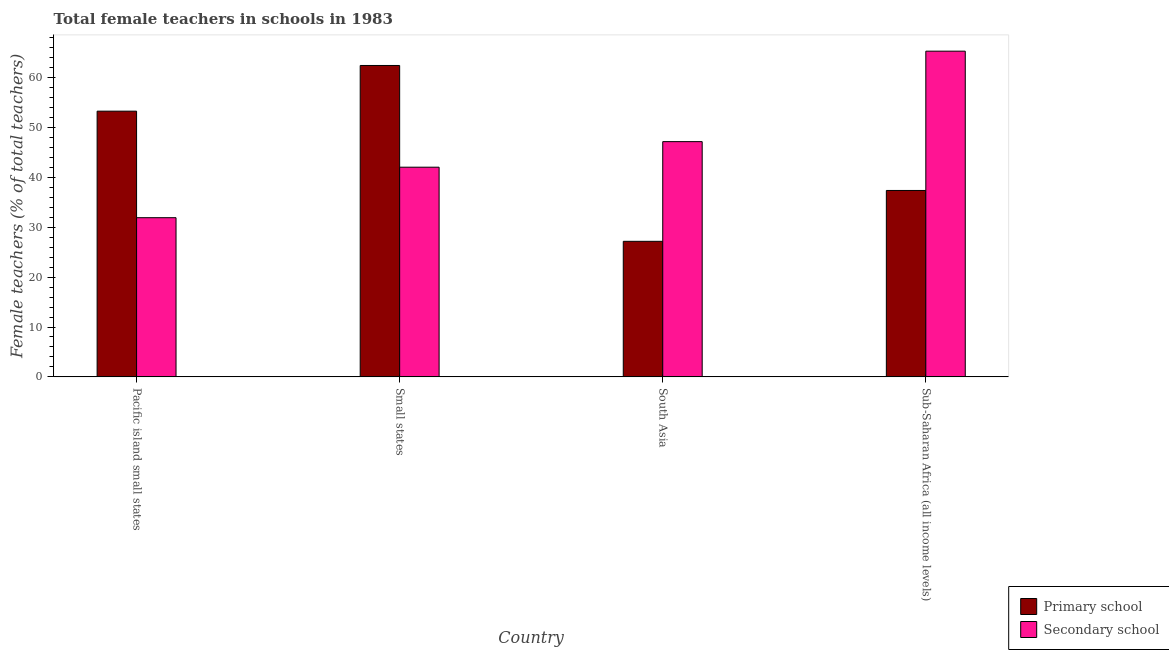How many different coloured bars are there?
Your response must be concise. 2. How many groups of bars are there?
Ensure brevity in your answer.  4. Are the number of bars per tick equal to the number of legend labels?
Your answer should be very brief. Yes. Are the number of bars on each tick of the X-axis equal?
Your response must be concise. Yes. How many bars are there on the 4th tick from the left?
Your answer should be very brief. 2. What is the label of the 4th group of bars from the left?
Give a very brief answer. Sub-Saharan Africa (all income levels). In how many cases, is the number of bars for a given country not equal to the number of legend labels?
Your answer should be very brief. 0. What is the percentage of female teachers in primary schools in Sub-Saharan Africa (all income levels)?
Give a very brief answer. 37.4. Across all countries, what is the maximum percentage of female teachers in primary schools?
Your answer should be very brief. 62.47. Across all countries, what is the minimum percentage of female teachers in primary schools?
Offer a terse response. 27.19. In which country was the percentage of female teachers in secondary schools maximum?
Ensure brevity in your answer.  Sub-Saharan Africa (all income levels). In which country was the percentage of female teachers in secondary schools minimum?
Your answer should be compact. Pacific island small states. What is the total percentage of female teachers in primary schools in the graph?
Offer a very short reply. 180.37. What is the difference between the percentage of female teachers in primary schools in Pacific island small states and that in Sub-Saharan Africa (all income levels)?
Your answer should be compact. 15.91. What is the difference between the percentage of female teachers in primary schools in Small states and the percentage of female teachers in secondary schools in South Asia?
Give a very brief answer. 15.28. What is the average percentage of female teachers in secondary schools per country?
Make the answer very short. 46.63. What is the difference between the percentage of female teachers in primary schools and percentage of female teachers in secondary schools in Small states?
Give a very brief answer. 20.41. What is the ratio of the percentage of female teachers in primary schools in South Asia to that in Sub-Saharan Africa (all income levels)?
Your answer should be compact. 0.73. Is the difference between the percentage of female teachers in primary schools in Pacific island small states and Sub-Saharan Africa (all income levels) greater than the difference between the percentage of female teachers in secondary schools in Pacific island small states and Sub-Saharan Africa (all income levels)?
Provide a succinct answer. Yes. What is the difference between the highest and the second highest percentage of female teachers in secondary schools?
Your answer should be very brief. 18.15. What is the difference between the highest and the lowest percentage of female teachers in secondary schools?
Provide a short and direct response. 33.41. In how many countries, is the percentage of female teachers in primary schools greater than the average percentage of female teachers in primary schools taken over all countries?
Your response must be concise. 2. Is the sum of the percentage of female teachers in primary schools in Pacific island small states and Sub-Saharan Africa (all income levels) greater than the maximum percentage of female teachers in secondary schools across all countries?
Make the answer very short. Yes. What does the 1st bar from the left in Pacific island small states represents?
Provide a short and direct response. Primary school. What does the 2nd bar from the right in South Asia represents?
Provide a succinct answer. Primary school. How many countries are there in the graph?
Provide a succinct answer. 4. What is the difference between two consecutive major ticks on the Y-axis?
Keep it short and to the point. 10. Does the graph contain any zero values?
Keep it short and to the point. No. Where does the legend appear in the graph?
Provide a succinct answer. Bottom right. How many legend labels are there?
Ensure brevity in your answer.  2. How are the legend labels stacked?
Keep it short and to the point. Vertical. What is the title of the graph?
Keep it short and to the point. Total female teachers in schools in 1983. Does "GDP at market prices" appear as one of the legend labels in the graph?
Offer a very short reply. No. What is the label or title of the Y-axis?
Give a very brief answer. Female teachers (% of total teachers). What is the Female teachers (% of total teachers) in Primary school in Pacific island small states?
Your response must be concise. 53.31. What is the Female teachers (% of total teachers) of Secondary school in Pacific island small states?
Provide a short and direct response. 31.94. What is the Female teachers (% of total teachers) in Primary school in Small states?
Your answer should be very brief. 62.47. What is the Female teachers (% of total teachers) in Secondary school in Small states?
Provide a short and direct response. 42.07. What is the Female teachers (% of total teachers) of Primary school in South Asia?
Make the answer very short. 27.19. What is the Female teachers (% of total teachers) of Secondary school in South Asia?
Provide a succinct answer. 47.19. What is the Female teachers (% of total teachers) of Primary school in Sub-Saharan Africa (all income levels)?
Make the answer very short. 37.4. What is the Female teachers (% of total teachers) in Secondary school in Sub-Saharan Africa (all income levels)?
Make the answer very short. 65.34. Across all countries, what is the maximum Female teachers (% of total teachers) in Primary school?
Offer a terse response. 62.47. Across all countries, what is the maximum Female teachers (% of total teachers) in Secondary school?
Offer a very short reply. 65.34. Across all countries, what is the minimum Female teachers (% of total teachers) of Primary school?
Give a very brief answer. 27.19. Across all countries, what is the minimum Female teachers (% of total teachers) in Secondary school?
Provide a succinct answer. 31.94. What is the total Female teachers (% of total teachers) in Primary school in the graph?
Offer a terse response. 180.37. What is the total Female teachers (% of total teachers) in Secondary school in the graph?
Make the answer very short. 186.54. What is the difference between the Female teachers (% of total teachers) of Primary school in Pacific island small states and that in Small states?
Offer a very short reply. -9.17. What is the difference between the Female teachers (% of total teachers) of Secondary school in Pacific island small states and that in Small states?
Provide a succinct answer. -10.13. What is the difference between the Female teachers (% of total teachers) of Primary school in Pacific island small states and that in South Asia?
Give a very brief answer. 26.11. What is the difference between the Female teachers (% of total teachers) in Secondary school in Pacific island small states and that in South Asia?
Give a very brief answer. -15.26. What is the difference between the Female teachers (% of total teachers) in Primary school in Pacific island small states and that in Sub-Saharan Africa (all income levels)?
Provide a short and direct response. 15.91. What is the difference between the Female teachers (% of total teachers) in Secondary school in Pacific island small states and that in Sub-Saharan Africa (all income levels)?
Ensure brevity in your answer.  -33.41. What is the difference between the Female teachers (% of total teachers) of Primary school in Small states and that in South Asia?
Keep it short and to the point. 35.28. What is the difference between the Female teachers (% of total teachers) of Secondary school in Small states and that in South Asia?
Your answer should be compact. -5.13. What is the difference between the Female teachers (% of total teachers) in Primary school in Small states and that in Sub-Saharan Africa (all income levels)?
Offer a terse response. 25.07. What is the difference between the Female teachers (% of total teachers) in Secondary school in Small states and that in Sub-Saharan Africa (all income levels)?
Offer a very short reply. -23.28. What is the difference between the Female teachers (% of total teachers) of Primary school in South Asia and that in Sub-Saharan Africa (all income levels)?
Your answer should be very brief. -10.2. What is the difference between the Female teachers (% of total teachers) in Secondary school in South Asia and that in Sub-Saharan Africa (all income levels)?
Offer a terse response. -18.15. What is the difference between the Female teachers (% of total teachers) of Primary school in Pacific island small states and the Female teachers (% of total teachers) of Secondary school in Small states?
Keep it short and to the point. 11.24. What is the difference between the Female teachers (% of total teachers) of Primary school in Pacific island small states and the Female teachers (% of total teachers) of Secondary school in South Asia?
Offer a terse response. 6.11. What is the difference between the Female teachers (% of total teachers) of Primary school in Pacific island small states and the Female teachers (% of total teachers) of Secondary school in Sub-Saharan Africa (all income levels)?
Your answer should be compact. -12.04. What is the difference between the Female teachers (% of total teachers) in Primary school in Small states and the Female teachers (% of total teachers) in Secondary school in South Asia?
Keep it short and to the point. 15.28. What is the difference between the Female teachers (% of total teachers) in Primary school in Small states and the Female teachers (% of total teachers) in Secondary school in Sub-Saharan Africa (all income levels)?
Provide a short and direct response. -2.87. What is the difference between the Female teachers (% of total teachers) of Primary school in South Asia and the Female teachers (% of total teachers) of Secondary school in Sub-Saharan Africa (all income levels)?
Offer a terse response. -38.15. What is the average Female teachers (% of total teachers) in Primary school per country?
Your answer should be very brief. 45.09. What is the average Female teachers (% of total teachers) of Secondary school per country?
Offer a terse response. 46.63. What is the difference between the Female teachers (% of total teachers) of Primary school and Female teachers (% of total teachers) of Secondary school in Pacific island small states?
Make the answer very short. 21.37. What is the difference between the Female teachers (% of total teachers) in Primary school and Female teachers (% of total teachers) in Secondary school in Small states?
Make the answer very short. 20.41. What is the difference between the Female teachers (% of total teachers) of Primary school and Female teachers (% of total teachers) of Secondary school in South Asia?
Keep it short and to the point. -20. What is the difference between the Female teachers (% of total teachers) in Primary school and Female teachers (% of total teachers) in Secondary school in Sub-Saharan Africa (all income levels)?
Make the answer very short. -27.95. What is the ratio of the Female teachers (% of total teachers) in Primary school in Pacific island small states to that in Small states?
Provide a succinct answer. 0.85. What is the ratio of the Female teachers (% of total teachers) of Secondary school in Pacific island small states to that in Small states?
Your response must be concise. 0.76. What is the ratio of the Female teachers (% of total teachers) of Primary school in Pacific island small states to that in South Asia?
Your answer should be very brief. 1.96. What is the ratio of the Female teachers (% of total teachers) of Secondary school in Pacific island small states to that in South Asia?
Provide a short and direct response. 0.68. What is the ratio of the Female teachers (% of total teachers) of Primary school in Pacific island small states to that in Sub-Saharan Africa (all income levels)?
Offer a terse response. 1.43. What is the ratio of the Female teachers (% of total teachers) in Secondary school in Pacific island small states to that in Sub-Saharan Africa (all income levels)?
Ensure brevity in your answer.  0.49. What is the ratio of the Female teachers (% of total teachers) of Primary school in Small states to that in South Asia?
Keep it short and to the point. 2.3. What is the ratio of the Female teachers (% of total teachers) in Secondary school in Small states to that in South Asia?
Your response must be concise. 0.89. What is the ratio of the Female teachers (% of total teachers) in Primary school in Small states to that in Sub-Saharan Africa (all income levels)?
Offer a terse response. 1.67. What is the ratio of the Female teachers (% of total teachers) of Secondary school in Small states to that in Sub-Saharan Africa (all income levels)?
Provide a short and direct response. 0.64. What is the ratio of the Female teachers (% of total teachers) in Primary school in South Asia to that in Sub-Saharan Africa (all income levels)?
Keep it short and to the point. 0.73. What is the ratio of the Female teachers (% of total teachers) of Secondary school in South Asia to that in Sub-Saharan Africa (all income levels)?
Keep it short and to the point. 0.72. What is the difference between the highest and the second highest Female teachers (% of total teachers) in Primary school?
Offer a terse response. 9.17. What is the difference between the highest and the second highest Female teachers (% of total teachers) of Secondary school?
Ensure brevity in your answer.  18.15. What is the difference between the highest and the lowest Female teachers (% of total teachers) in Primary school?
Your answer should be compact. 35.28. What is the difference between the highest and the lowest Female teachers (% of total teachers) in Secondary school?
Offer a terse response. 33.41. 